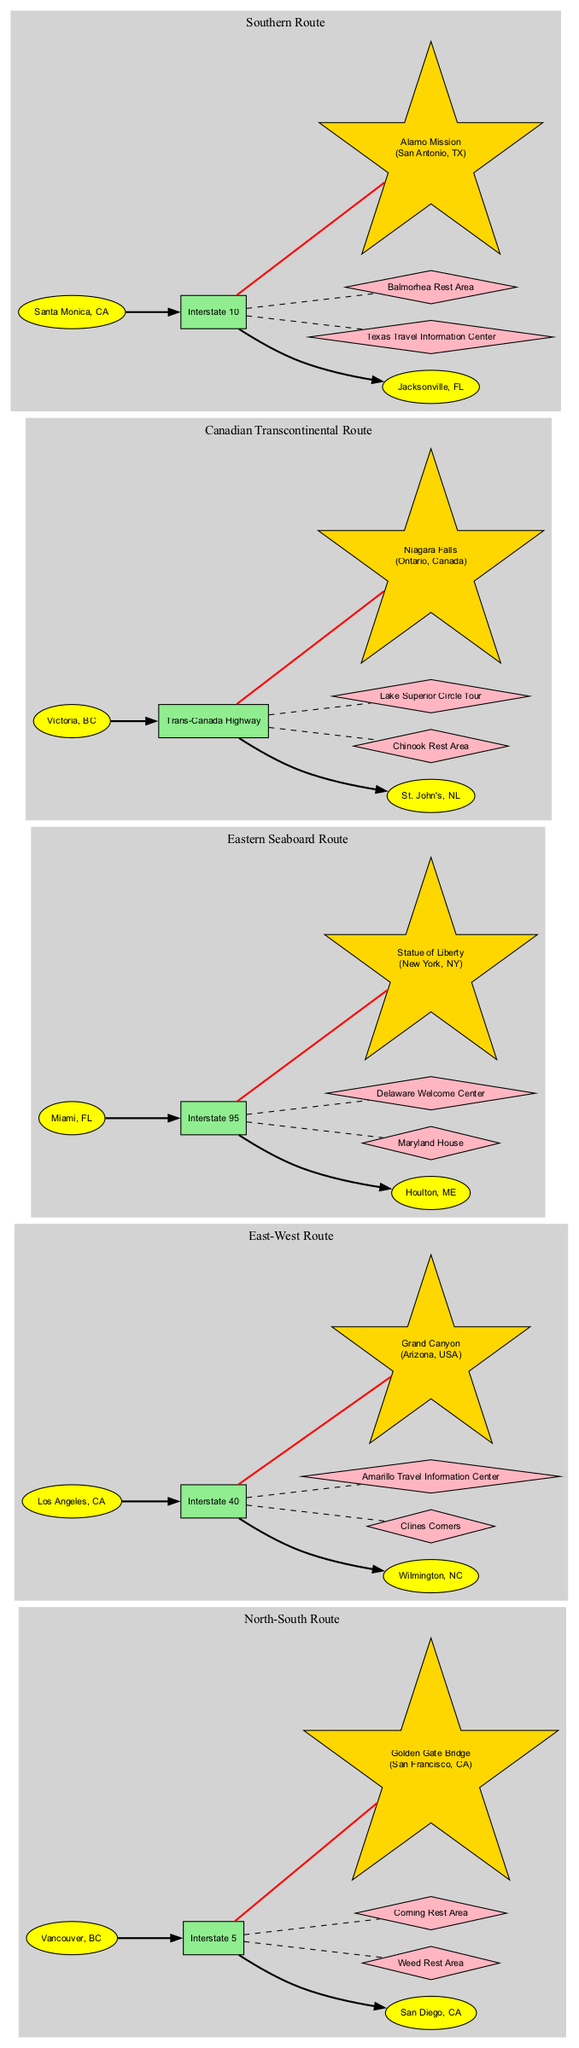What is the key landmark along Interstate 5? By examining the highway nodes for Interstate 5, we find that its corresponding key landmark is the Golden Gate Bridge.
Answer: Golden Gate Bridge How many rest stops are associated with Interstate 40? Looking at the metadata for Interstate 40, we can identify that it has two associated rest stops: Clines Corners and Amarillo Travel Information Center, leading to the conclusion there are two.
Answer: 2 Which truck-friendly route connects Vancouver, BC, to San Diego, CA? The diagram specifically labels the North-South Route as the one that connects these two locations, confirming its name.
Answer: North-South Route What color are the highway nodes depicted in the diagram? The custom node styling reveals that the highway nodes are displayed in light green.
Answer: Light green What is the total number of truck-friendly routes shown in the diagram? By counting the listed truck-friendly routes in the diagram, we can see there are five distinct routes depicted.
Answer: 5 Which highway has the key landmark Statue of Liberty? Upon reviewing the information, we can determine that the Statue of Liberty is located along Interstate 95, as indicated in the metadata for that highway.
Answer: Interstate 95 What is the starting point of the Southern Route? According to the diagram, the Southern Route starts from Santa Monica, CA, as clearly labeled.
Answer: Santa Monica, CA How many total rest stops are shown across all highways? By counting the unique rest stops from the provided data for each highway (two from Interstate 5, two from Interstate 40, two from Interstate 95, two from the Trans-Canada Highway, and two from Interstate 10), we find a total of ten rest stops.
Answer: 10 What landmark is associated with the Trans-Canada Highway? Reviewing the information, we see that Niagara Falls is identified as the key landmark associated with the Trans-Canada Highway.
Answer: Niagara Falls 